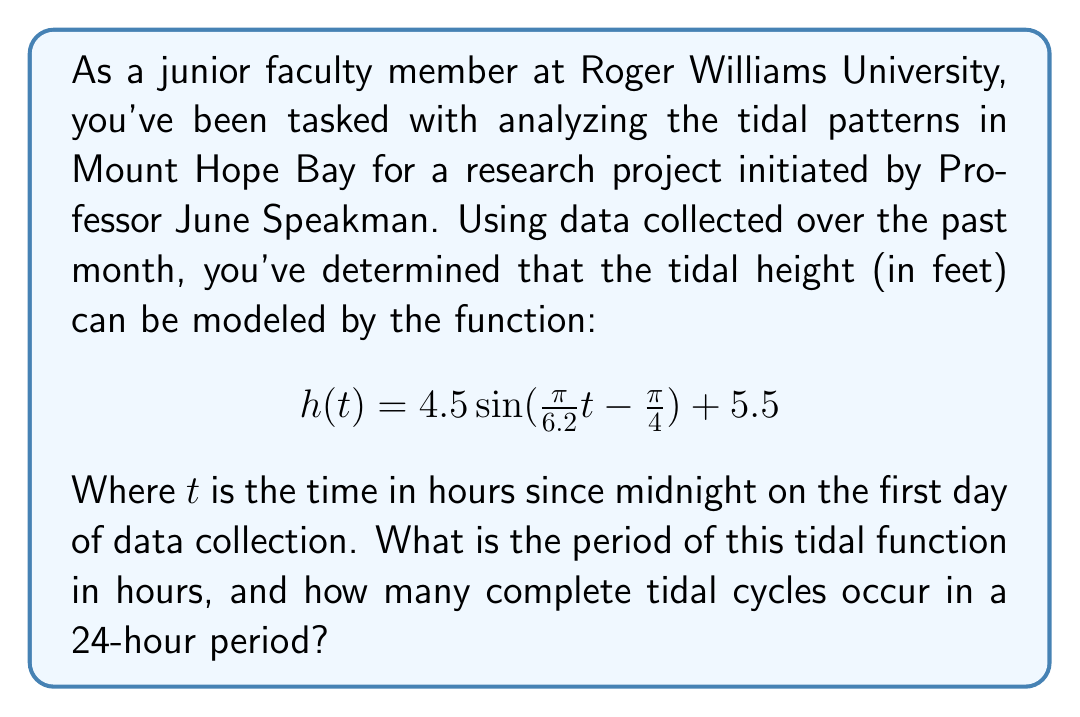What is the answer to this math problem? To solve this problem, we need to analyze the given trigonometric function:

$$h(t) = 4.5 \sin(\frac{\pi}{6.2}t - \frac{\pi}{4}) + 5.5$$

1) The general form of a sine function is:
   $$f(t) = A \sin(Bt - C) + D$$
   where $B$ determines the period of the function.

2) In our case, $B = \frac{\pi}{6.2}$

3) The period of a sine function is given by the formula:
   $$\text{Period} = \frac{2\pi}{|B|}$$

4) Substituting our value of $B$:
   $$\text{Period} = \frac{2\pi}{|\frac{\pi}{6.2}|} = \frac{2\pi}{\frac{\pi}{6.2}} = 2 \cdot 6.2 = 12.4 \text{ hours}$$

5) To find how many complete tidal cycles occur in a 24-hour period, we divide 24 by the period:
   $$\text{Number of cycles} = \frac{24}{12.4} \approx 1.935$$

6) This means that approximately 1.935 complete tidal cycles occur in a 24-hour period.
Answer: The period of the tidal function is 12.4 hours, and approximately 1.935 complete tidal cycles occur in a 24-hour period. 